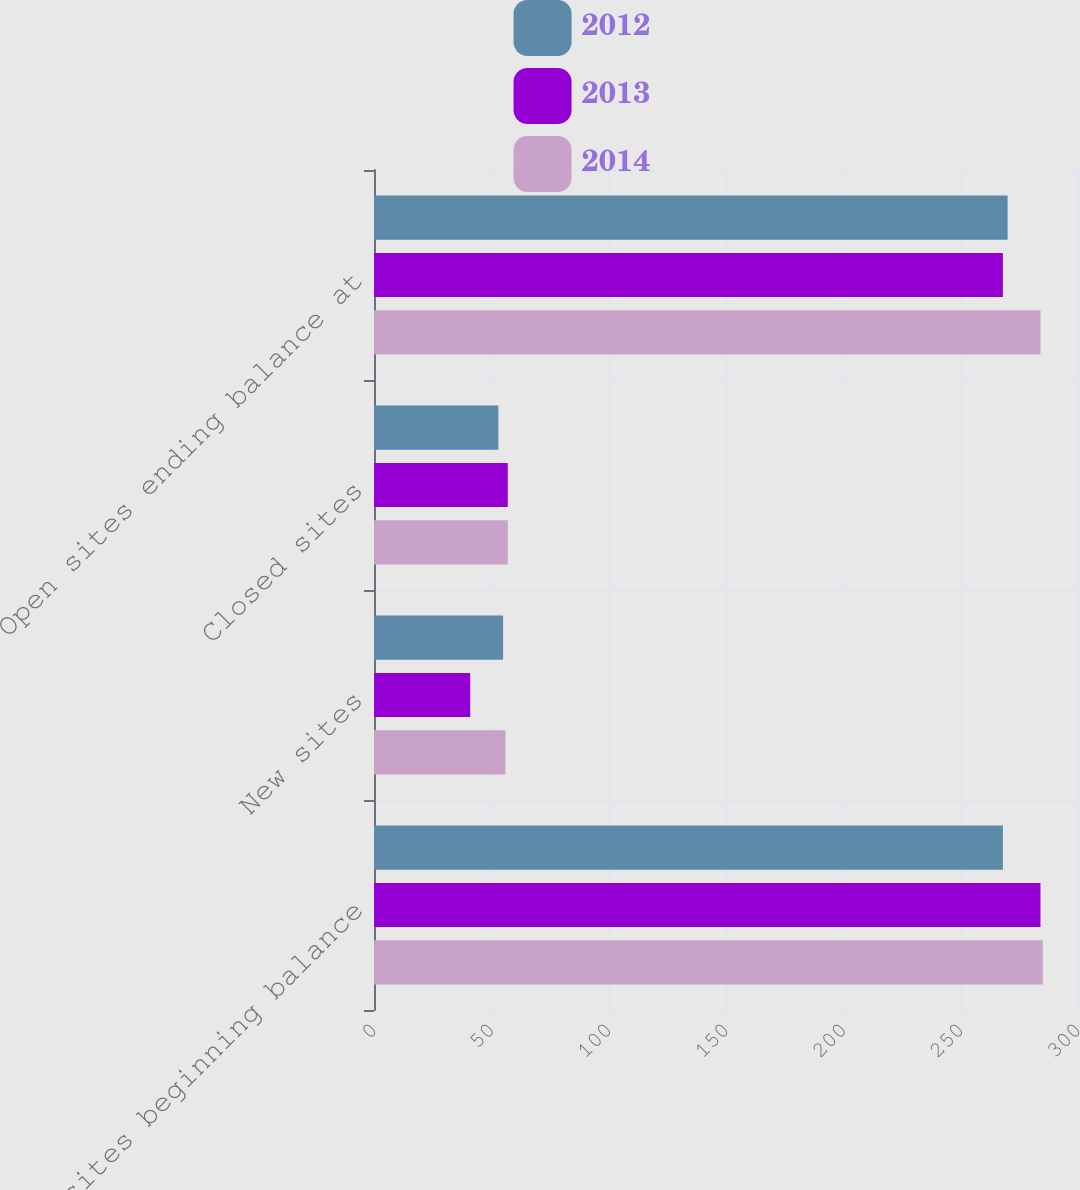Convert chart. <chart><loc_0><loc_0><loc_500><loc_500><stacked_bar_chart><ecel><fcel>Open sites beginning balance<fcel>New sites<fcel>Closed sites<fcel>Open sites ending balance at<nl><fcel>2012<fcel>268<fcel>55<fcel>53<fcel>270<nl><fcel>2013<fcel>284<fcel>41<fcel>57<fcel>268<nl><fcel>2014<fcel>285<fcel>56<fcel>57<fcel>284<nl></chart> 